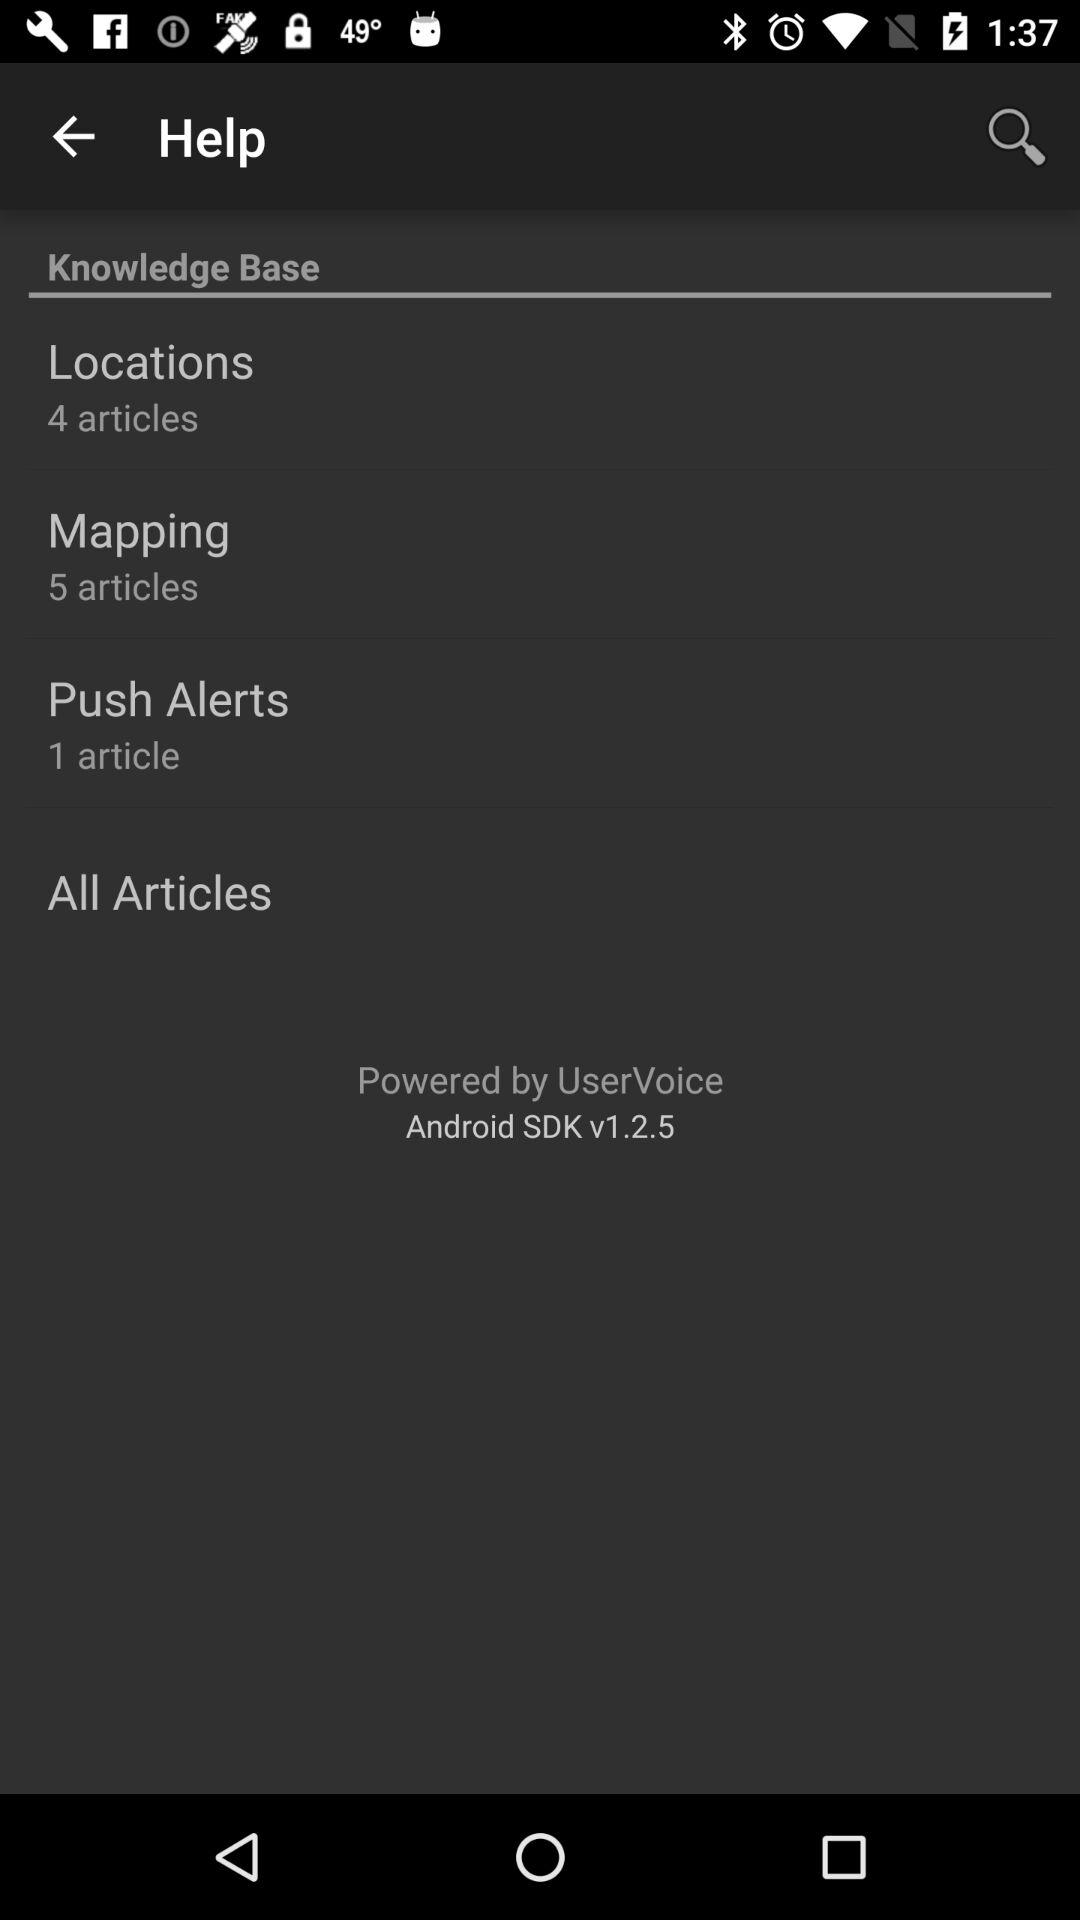How many articles are in the Push Alerts section? The Push Alerts section contains a single article. This concise overview suggests a focused topic or a specialized area of the knowledge base. 